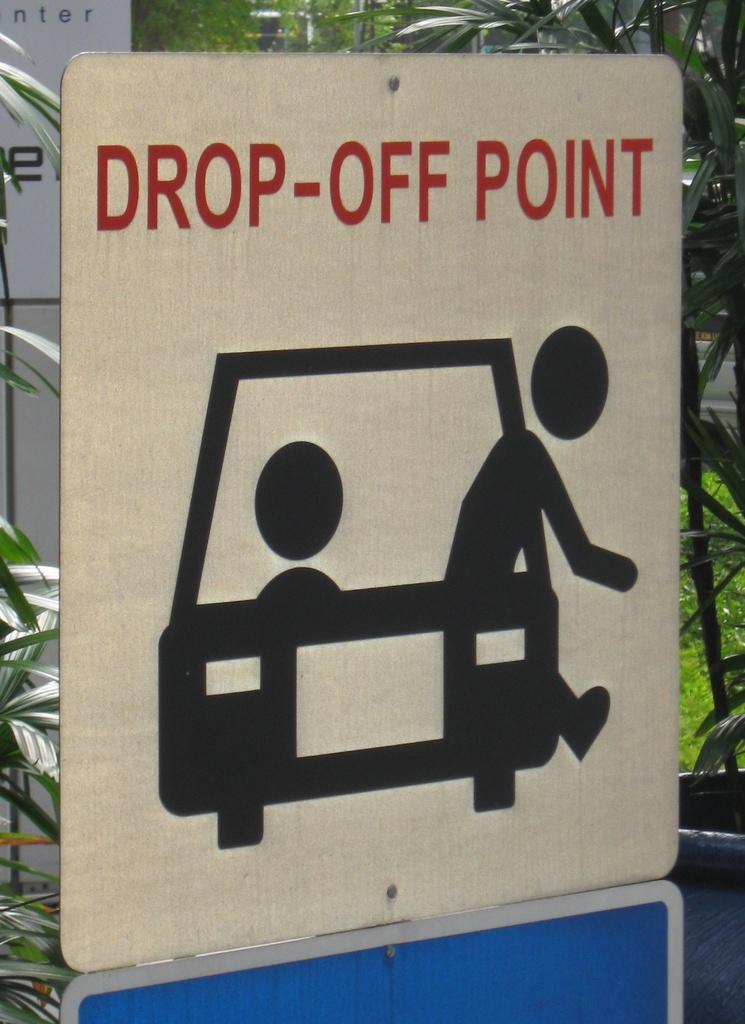<image>
Create a compact narrative representing the image presented. A sign indicates where drivers can drop passengers from their vehicles. 